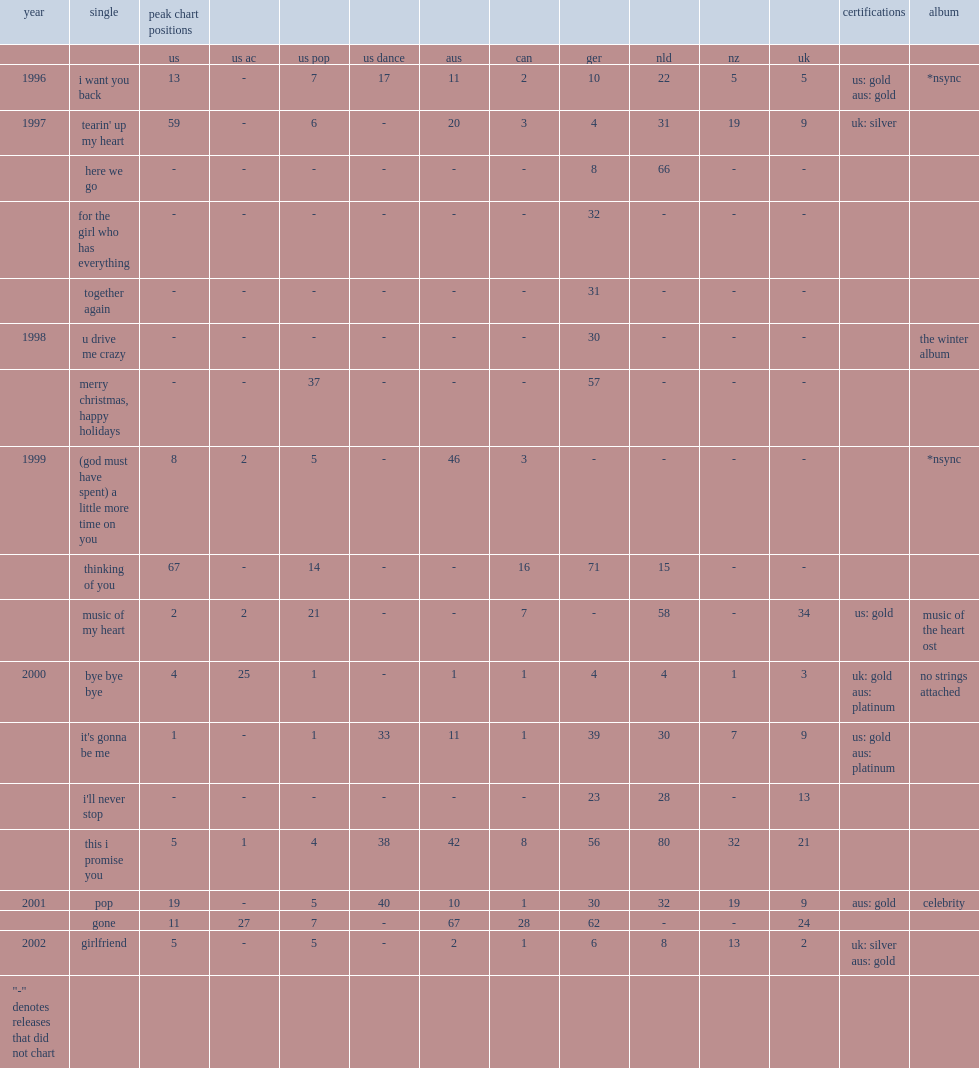Which album was nsync single "bye bye bye" released from in 2000? No strings attached. 